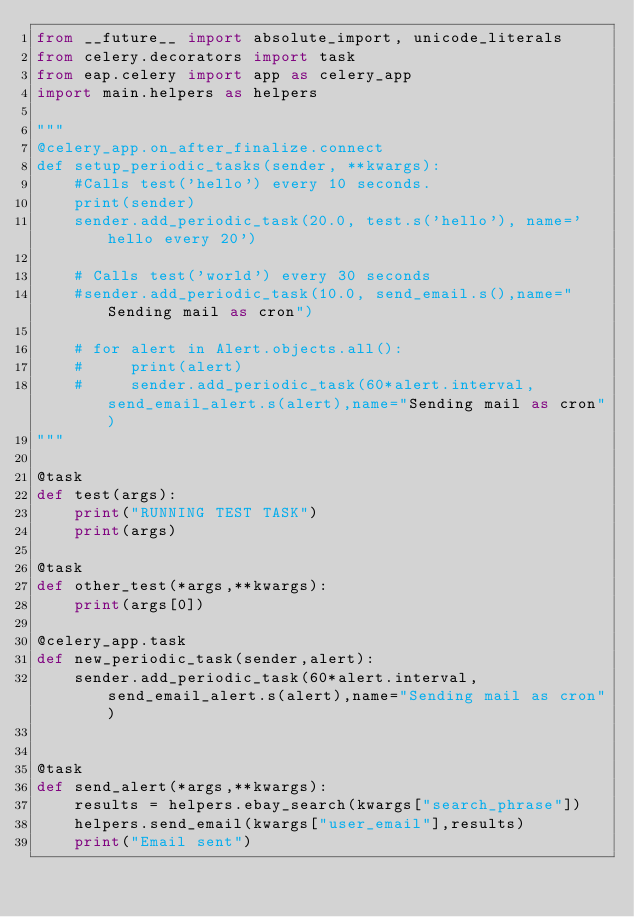<code> <loc_0><loc_0><loc_500><loc_500><_Python_>from __future__ import absolute_import, unicode_literals
from celery.decorators import task
from eap.celery import app as celery_app
import main.helpers as helpers

"""
@celery_app.on_after_finalize.connect
def setup_periodic_tasks(sender, **kwargs):
    #Calls test('hello') every 10 seconds.
    print(sender)
    sender.add_periodic_task(20.0, test.s('hello'), name='hello every 20')

    # Calls test('world') every 30 seconds
    #sender.add_periodic_task(10.0, send_email.s(),name="Sending mail as cron")

    # for alert in Alert.objects.all():
    #     print(alert)
    #     sender.add_periodic_task(60*alert.interval, send_email_alert.s(alert),name="Sending mail as cron")
"""

@task
def test(args):
    print("RUNNING TEST TASK")
    print(args)

@task
def other_test(*args,**kwargs):
    print(args[0])

@celery_app.task
def new_periodic_task(sender,alert):
    sender.add_periodic_task(60*alert.interval, send_email_alert.s(alert),name="Sending mail as cron")


@task
def send_alert(*args,**kwargs):
    results = helpers.ebay_search(kwargs["search_phrase"])
    helpers.send_email(kwargs["user_email"],results)
    print("Email sent")
</code> 